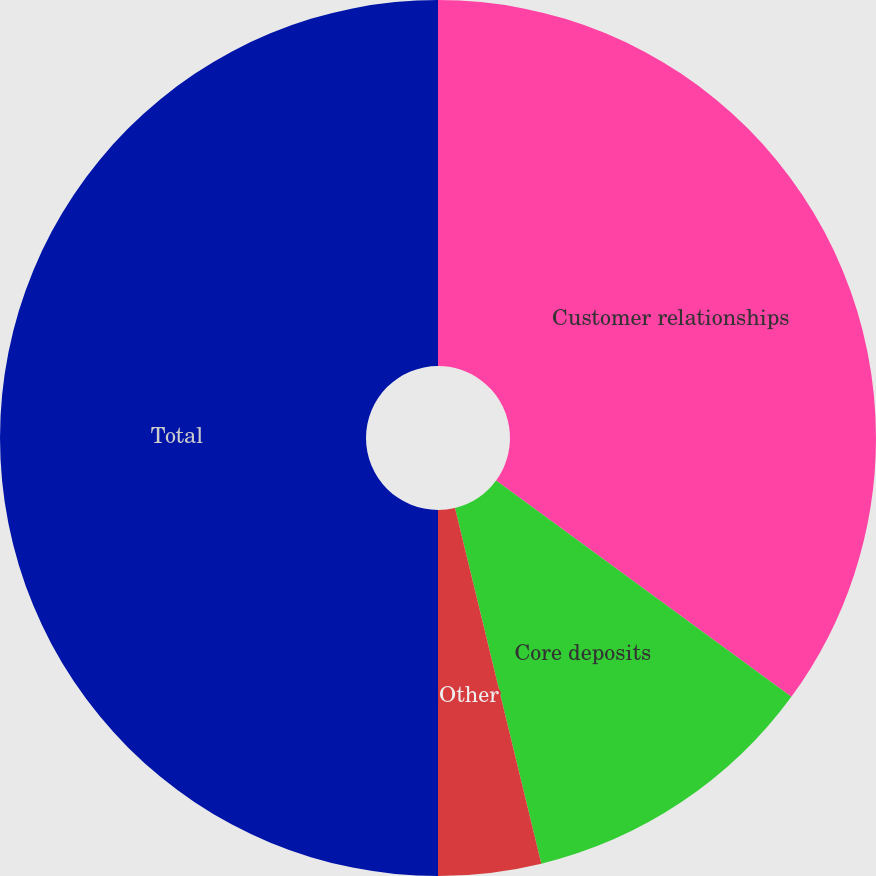Convert chart to OTSL. <chart><loc_0><loc_0><loc_500><loc_500><pie_chart><fcel>Customer relationships<fcel>Core deposits<fcel>Other<fcel>Total<nl><fcel>35.06%<fcel>11.15%<fcel>3.79%<fcel>50.0%<nl></chart> 